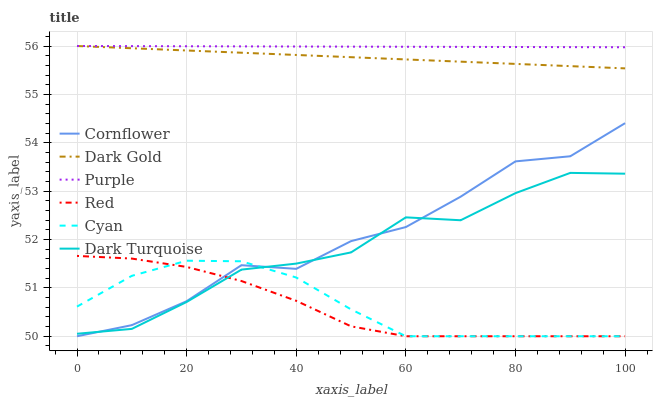Does Red have the minimum area under the curve?
Answer yes or no. Yes. Does Purple have the maximum area under the curve?
Answer yes or no. Yes. Does Dark Gold have the minimum area under the curve?
Answer yes or no. No. Does Dark Gold have the maximum area under the curve?
Answer yes or no. No. Is Purple the smoothest?
Answer yes or no. Yes. Is Cornflower the roughest?
Answer yes or no. Yes. Is Dark Gold the smoothest?
Answer yes or no. No. Is Dark Gold the roughest?
Answer yes or no. No. Does Cornflower have the lowest value?
Answer yes or no. Yes. Does Dark Gold have the lowest value?
Answer yes or no. No. Does Purple have the highest value?
Answer yes or no. Yes. Does Dark Turquoise have the highest value?
Answer yes or no. No. Is Cornflower less than Purple?
Answer yes or no. Yes. Is Purple greater than Cyan?
Answer yes or no. Yes. Does Dark Turquoise intersect Red?
Answer yes or no. Yes. Is Dark Turquoise less than Red?
Answer yes or no. No. Is Dark Turquoise greater than Red?
Answer yes or no. No. Does Cornflower intersect Purple?
Answer yes or no. No. 